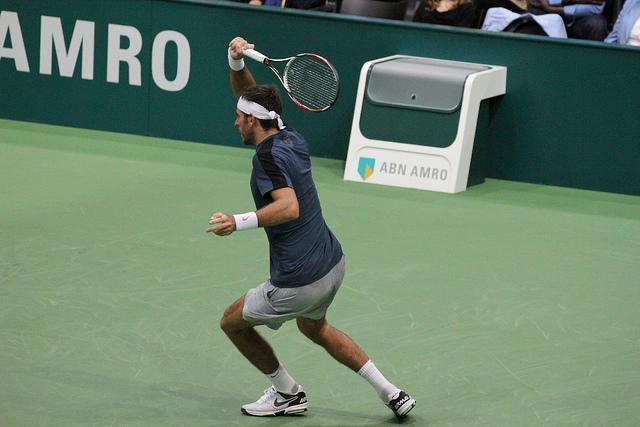What bank is a sponsor of the tennis event?
Choose the correct response, then elucidate: 'Answer: answer
Rationale: rationale.'
Options: Chase, wells fargo, citibank, abn amro. Answer: abn amro.
Rationale: You can see the letters of the name on the items on the court 